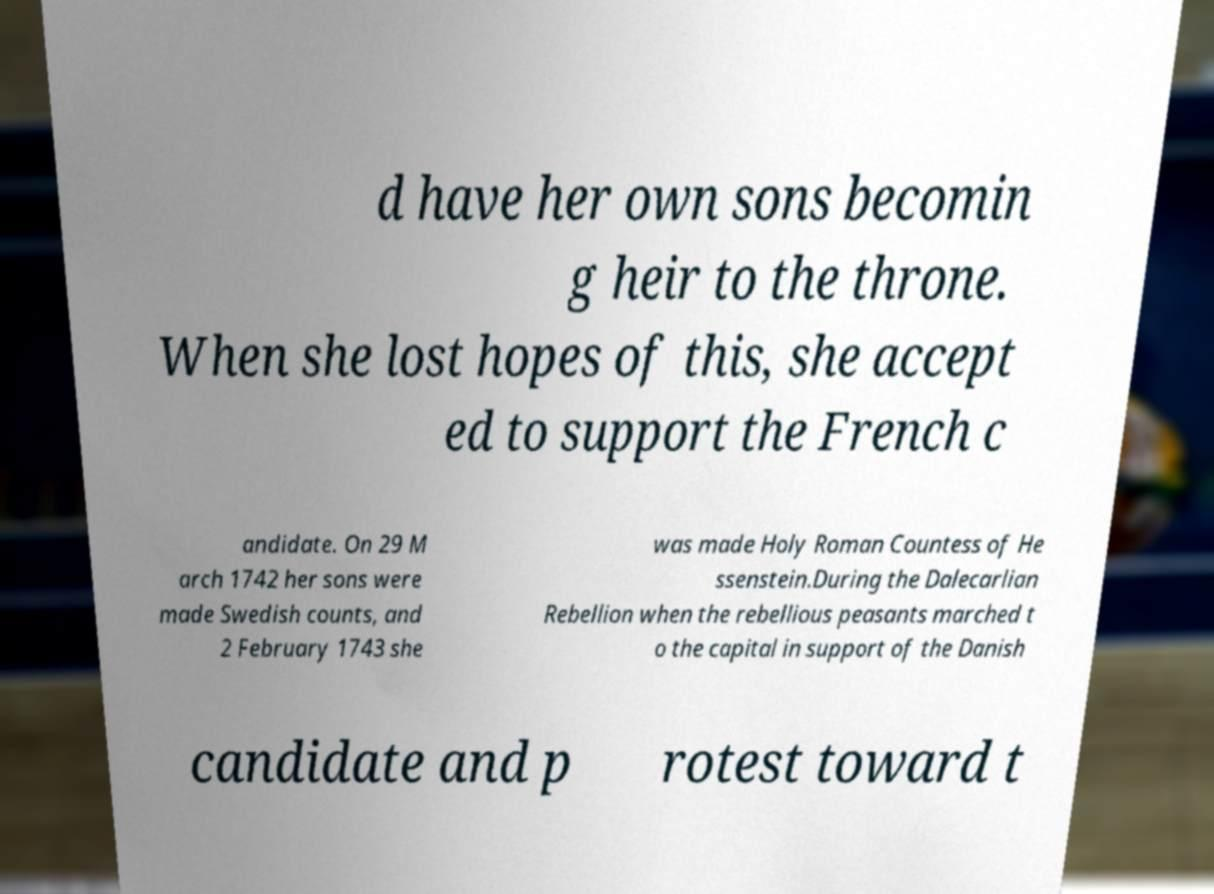Could you extract and type out the text from this image? d have her own sons becomin g heir to the throne. When she lost hopes of this, she accept ed to support the French c andidate. On 29 M arch 1742 her sons were made Swedish counts, and 2 February 1743 she was made Holy Roman Countess of He ssenstein.During the Dalecarlian Rebellion when the rebellious peasants marched t o the capital in support of the Danish candidate and p rotest toward t 